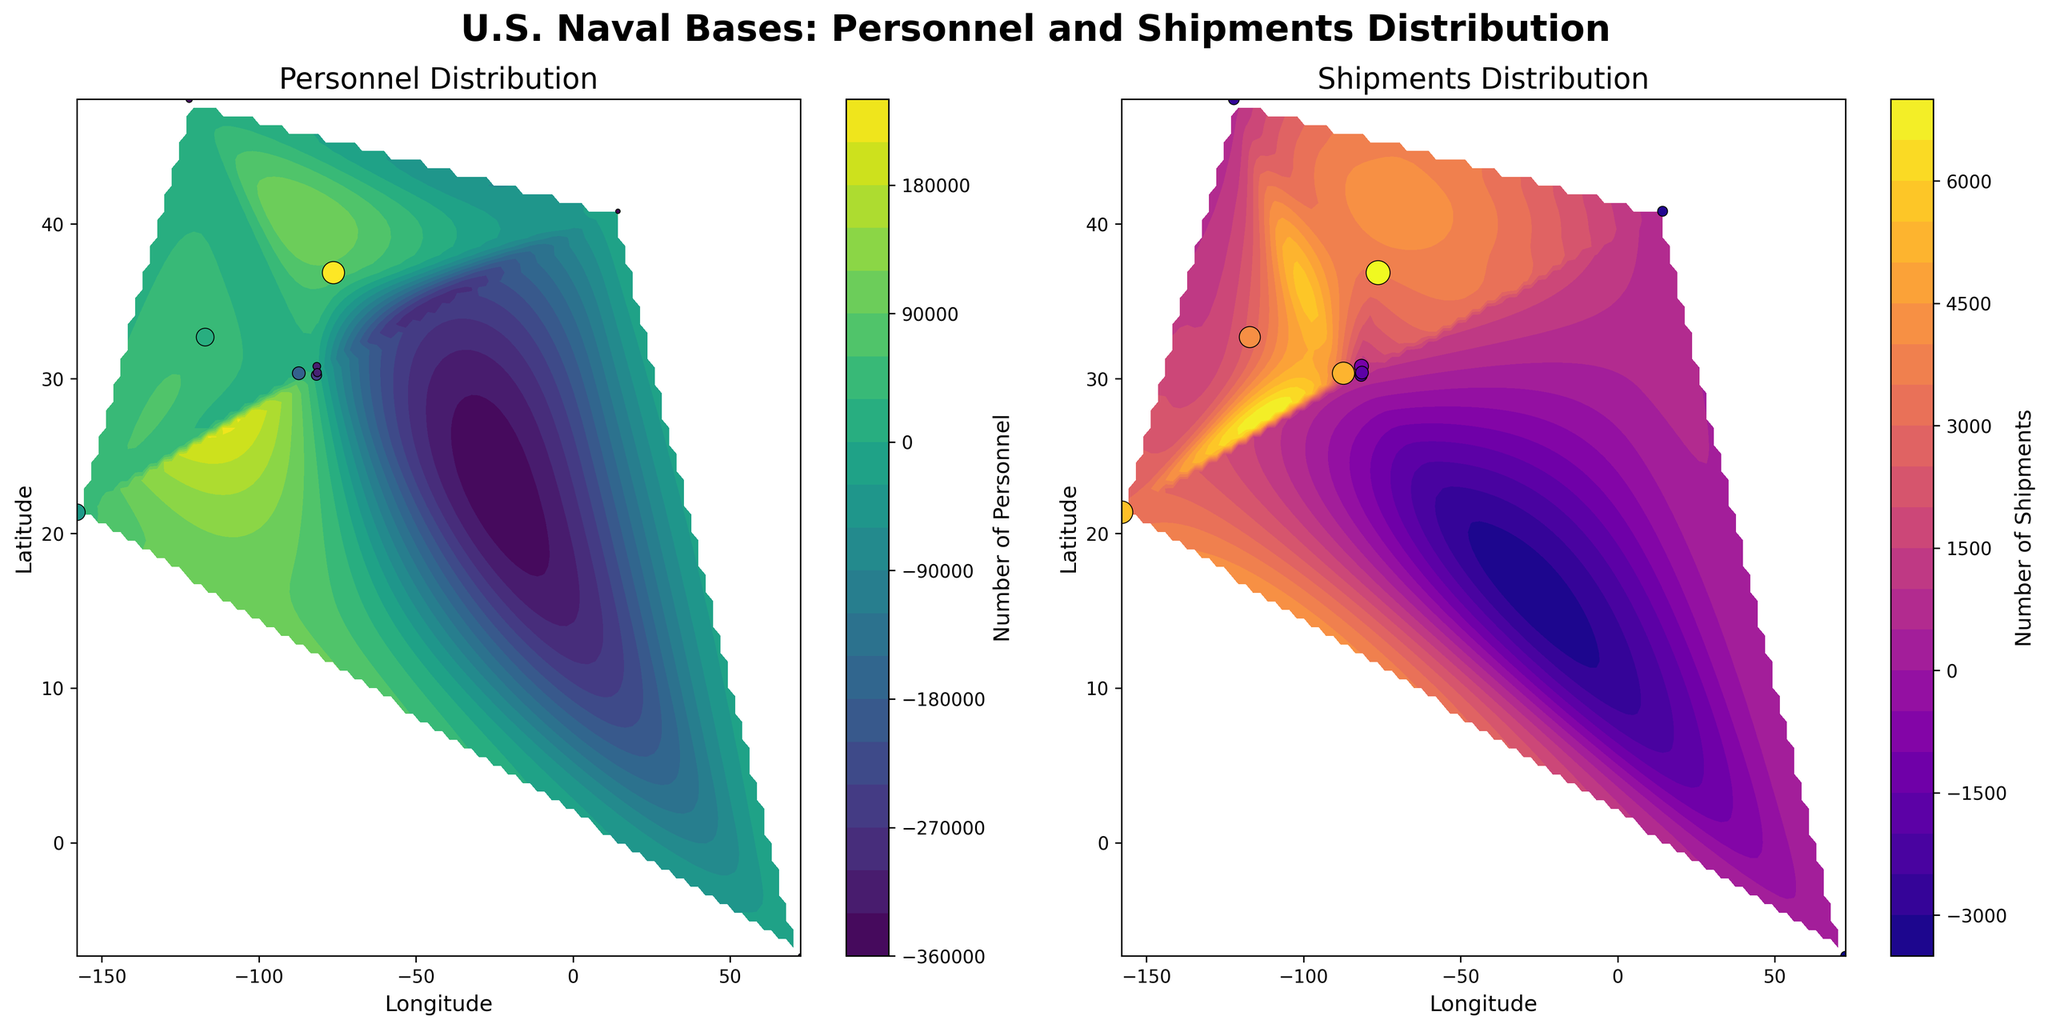What is the title of the figure? The title is prominently displayed at the top of the figure in bold font. It provides a quick summary of the content depicted in the figure.
Answer: U.S. Naval Bases: Personnel and Shipments Distribution How many subplots are there and what are they titled? The figure consists of two subplots side by side. Titles are located at the top of each subplot. The left subplot is titled "Personnel Distribution" and the right subplot is titled "Shipments Distribution."
Answer: 2; Personnel Distribution; Shipments Distribution Where is Naval Base Pearl Harbor located on the Personnel Distribution subplot? Naval Base Pearl Harbor's location can be found by looking for its coordinates (Longitude: -157.9448, Latitude: 21.3647). In the left subplot, this translates to a point in the southern region with moderately high personnel density based on contour shading.
Answer: Southern region Which naval base has the highest number of personnel and where is it located on the subplot? By observing the personnel color-coded dots, Naval Station Norfolk stands out with the highest personnel count. Its coordinates place it near the center-right of the personnel subplot.
Answer: Naval Station Norfolk; center-right Compare the personnel distribution between the eastern and western coasts. Which coast has a higher density? By examining contour levels and dot sizes in the left subplot, the eastern coast exhibits more closely packed high-level contour lines and larger dots, indicating a higher personnel density.
Answer: Eastern coast How does the shipment density vary between the southern and northern regions of the Shipment Distribution subplot? The right subplot contours show denser lines and more intense colors in the southern regions compared to the northern regions, indicating higher shipment densities in the south.
Answer: Southern regions have higher shipment densities What appears to be the range of personnel in the subplot based on the color bar? The color bar on the left subplot indicates personnel numbers range from the lowest (darker colors) to the highest (lighter colors). It's possible to estimate values by the gradient on the color bar.
Answer: Varies from low to high numbers (exact values not specified) Which naval base shows the least number of shipments and how is it represented in the Shipment Distribution subplot? By looking for the smallest dot and lowest color gradient intensity, Naval Support Facility Diego Garcia appears to have the least shipments. It can be seen as a small, dark dot on the right subplot.
Answer: Naval Support Facility Diego Garcia; small, dark dot How do the locations with the highest personnel compare with the locations with the highest shipments? Comparing the locations with intense contour lines and largest dots in both subplots reveals some overlap but also differences; for instance, Naval Station Norfolk is prominent in personnel but not the highest in shipments.
Answer: Overlap but not identical 